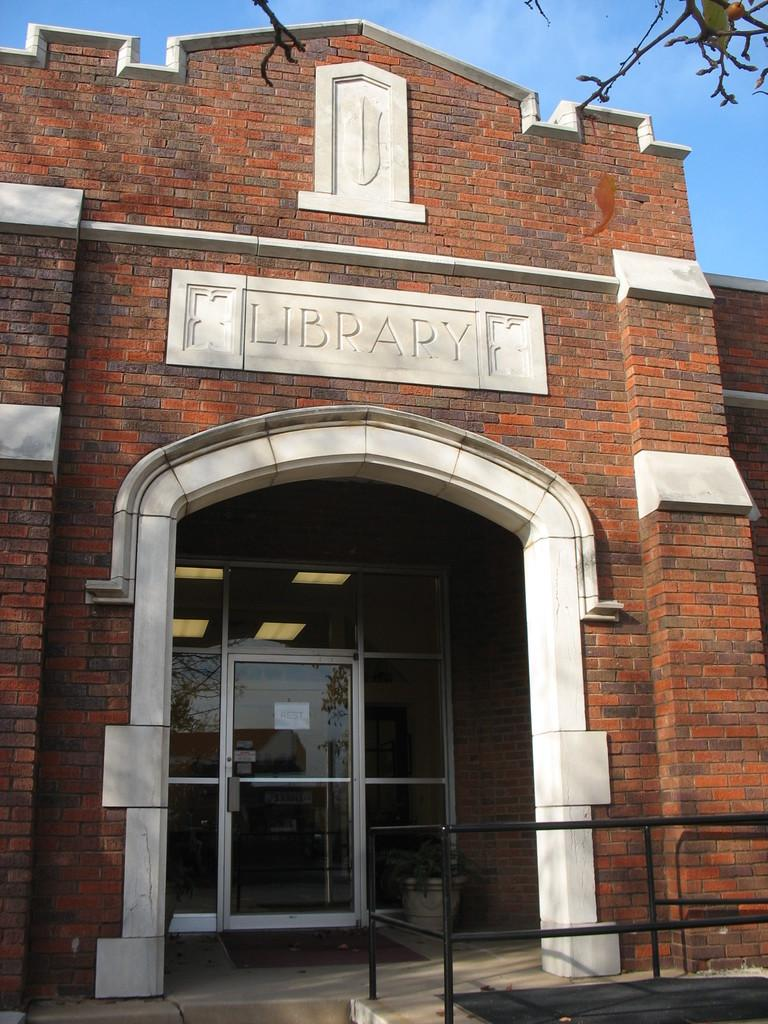<image>
Write a terse but informative summary of the picture. The brick and stone archway leading to a glass door entrance to a Library. 